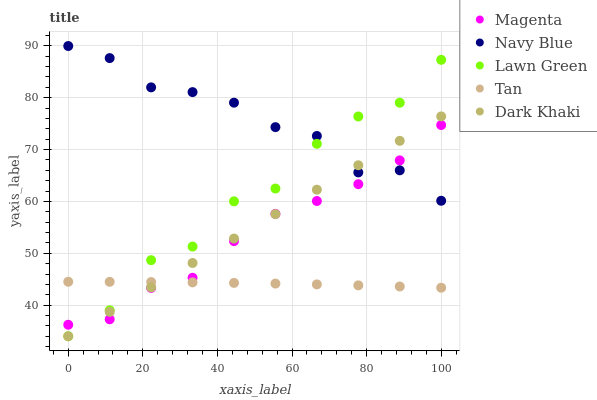Does Tan have the minimum area under the curve?
Answer yes or no. Yes. Does Navy Blue have the maximum area under the curve?
Answer yes or no. Yes. Does Magenta have the minimum area under the curve?
Answer yes or no. No. Does Magenta have the maximum area under the curve?
Answer yes or no. No. Is Dark Khaki the smoothest?
Answer yes or no. Yes. Is Lawn Green the roughest?
Answer yes or no. Yes. Is Navy Blue the smoothest?
Answer yes or no. No. Is Navy Blue the roughest?
Answer yes or no. No. Does Dark Khaki have the lowest value?
Answer yes or no. Yes. Does Magenta have the lowest value?
Answer yes or no. No. Does Navy Blue have the highest value?
Answer yes or no. Yes. Does Magenta have the highest value?
Answer yes or no. No. Is Tan less than Navy Blue?
Answer yes or no. Yes. Is Navy Blue greater than Tan?
Answer yes or no. Yes. Does Magenta intersect Navy Blue?
Answer yes or no. Yes. Is Magenta less than Navy Blue?
Answer yes or no. No. Is Magenta greater than Navy Blue?
Answer yes or no. No. Does Tan intersect Navy Blue?
Answer yes or no. No. 